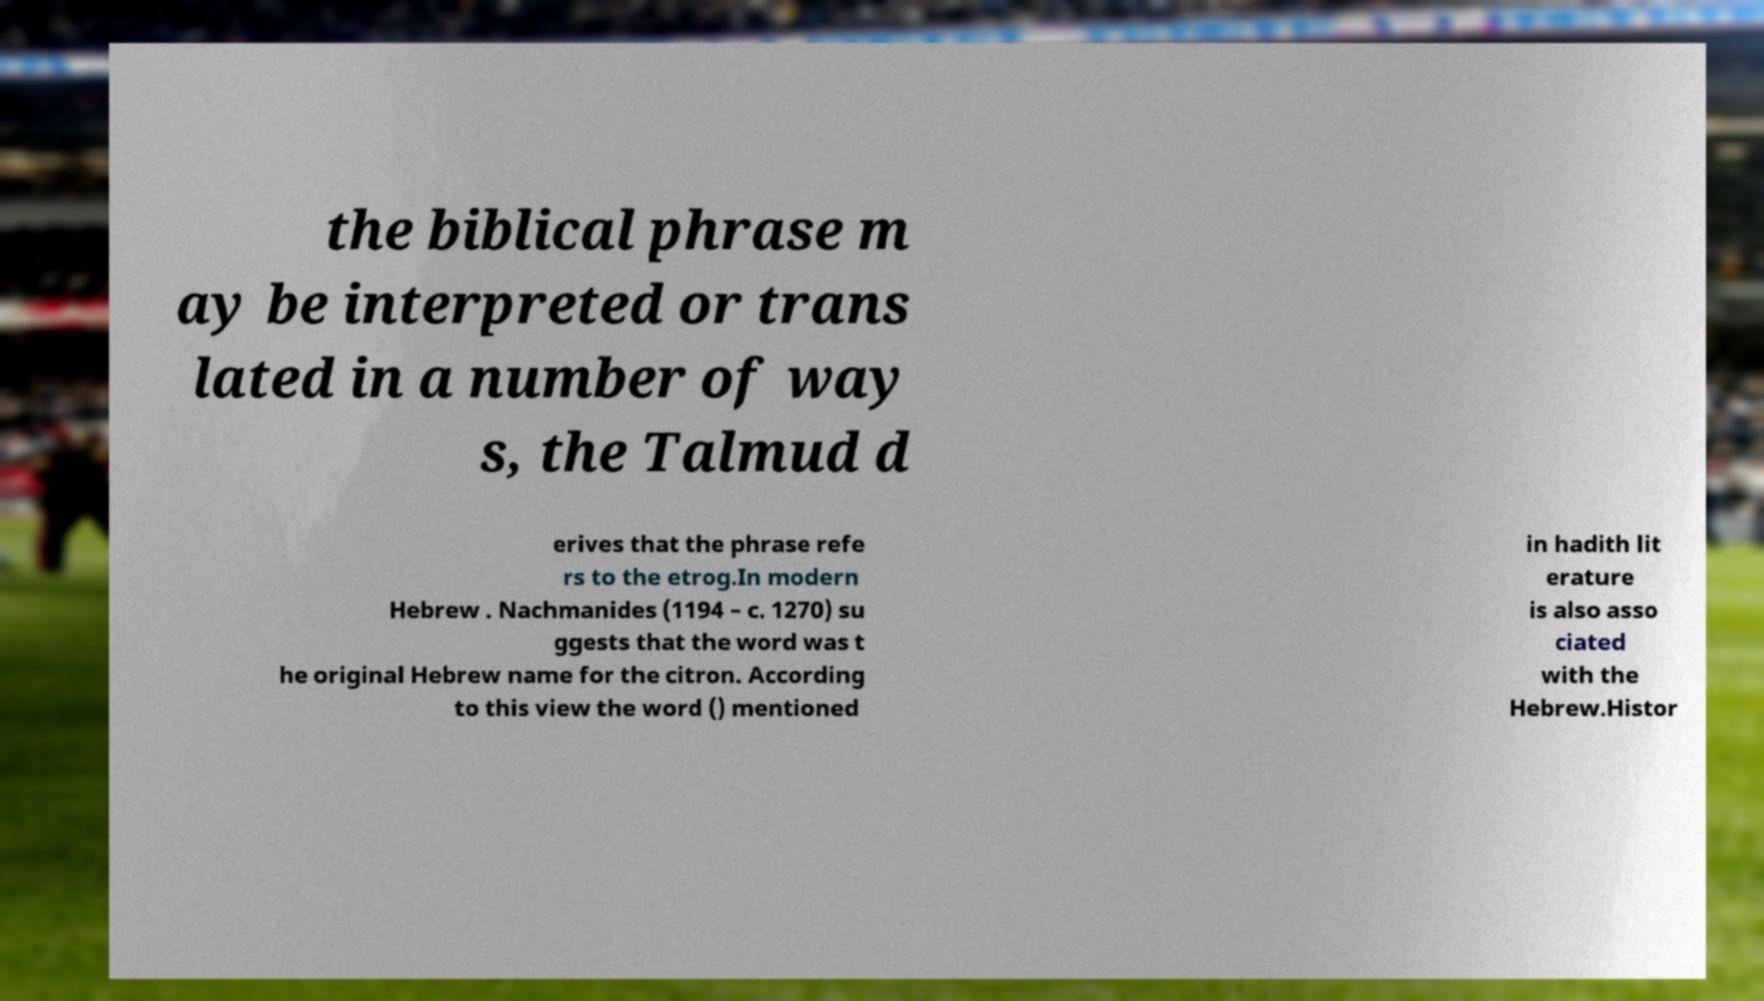Can you read and provide the text displayed in the image?This photo seems to have some interesting text. Can you extract and type it out for me? the biblical phrase m ay be interpreted or trans lated in a number of way s, the Talmud d erives that the phrase refe rs to the etrog.In modern Hebrew . Nachmanides (1194 – c. 1270) su ggests that the word was t he original Hebrew name for the citron. According to this view the word () mentioned in hadith lit erature is also asso ciated with the Hebrew.Histor 